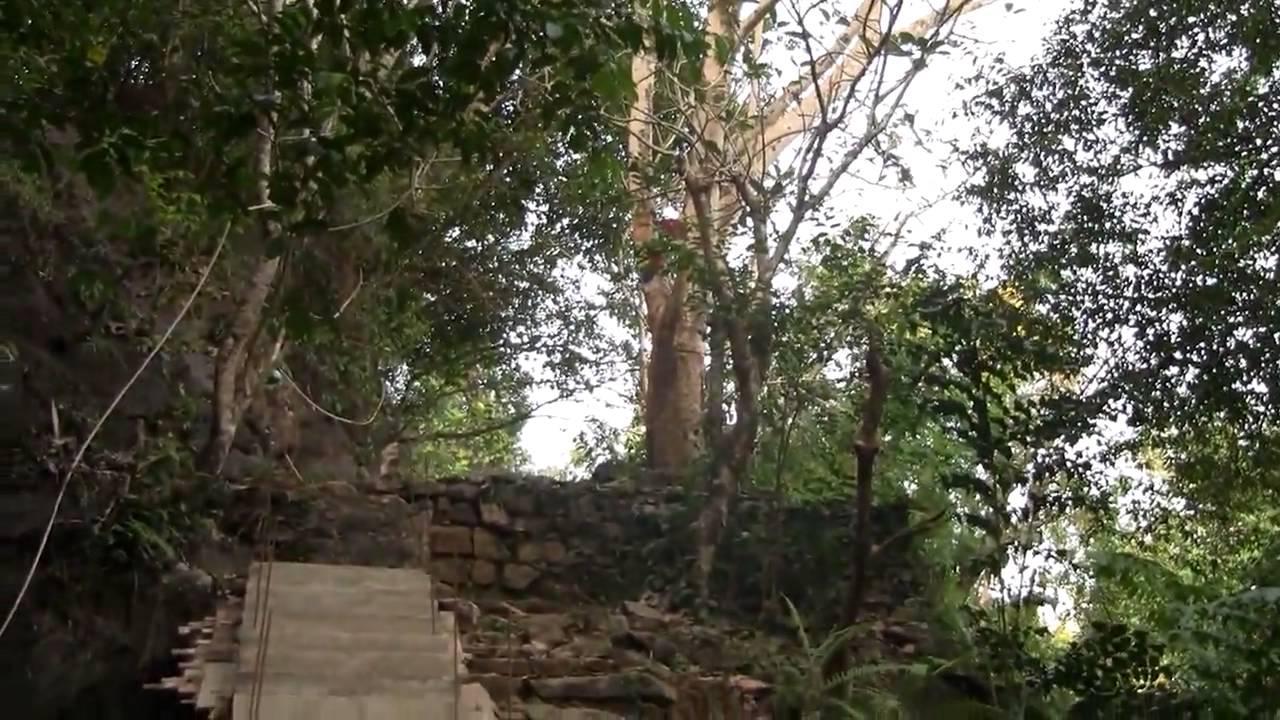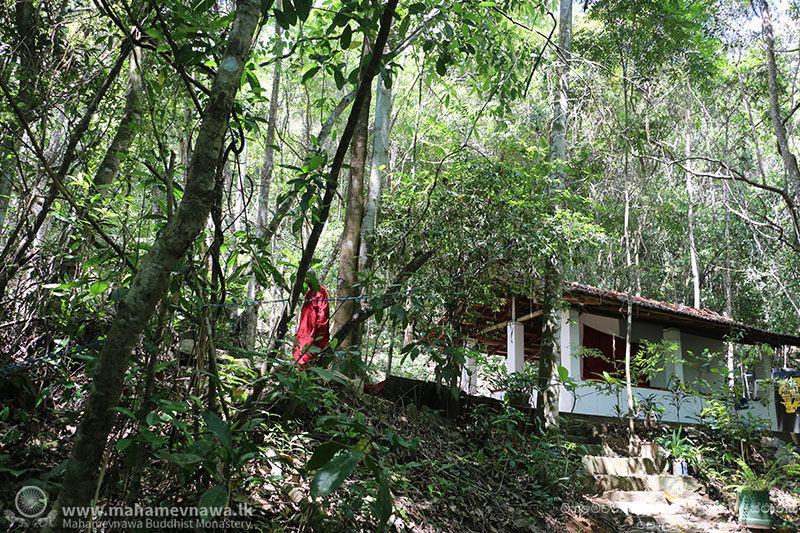The first image is the image on the left, the second image is the image on the right. Considering the images on both sides, is "In the right image, a figure is sitting in a lotus position on an elevated platform surrounded by foliage and curving vines." valid? Answer yes or no. No. 